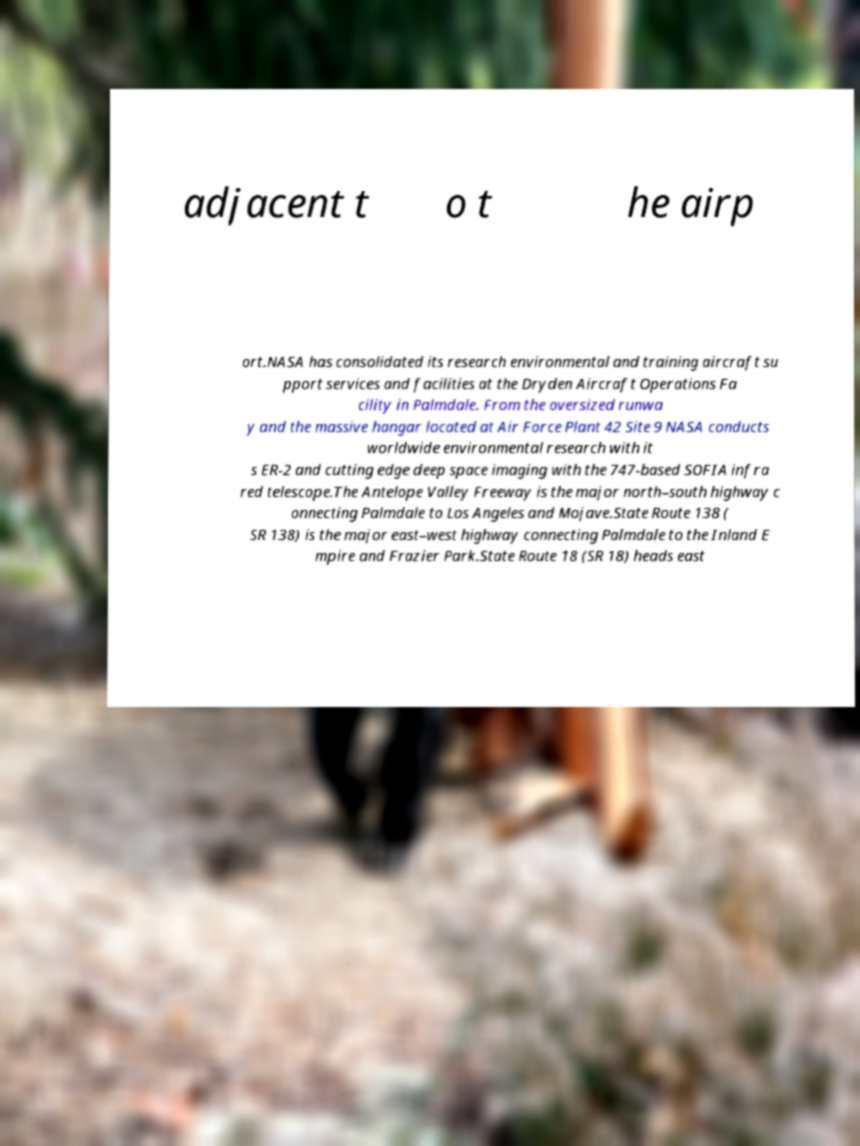Could you extract and type out the text from this image? adjacent t o t he airp ort.NASA has consolidated its research environmental and training aircraft su pport services and facilities at the Dryden Aircraft Operations Fa cility in Palmdale. From the oversized runwa y and the massive hangar located at Air Force Plant 42 Site 9 NASA conducts worldwide environmental research with it s ER-2 and cutting edge deep space imaging with the 747-based SOFIA infra red telescope.The Antelope Valley Freeway is the major north–south highway c onnecting Palmdale to Los Angeles and Mojave.State Route 138 ( SR 138) is the major east–west highway connecting Palmdale to the Inland E mpire and Frazier Park.State Route 18 (SR 18) heads east 